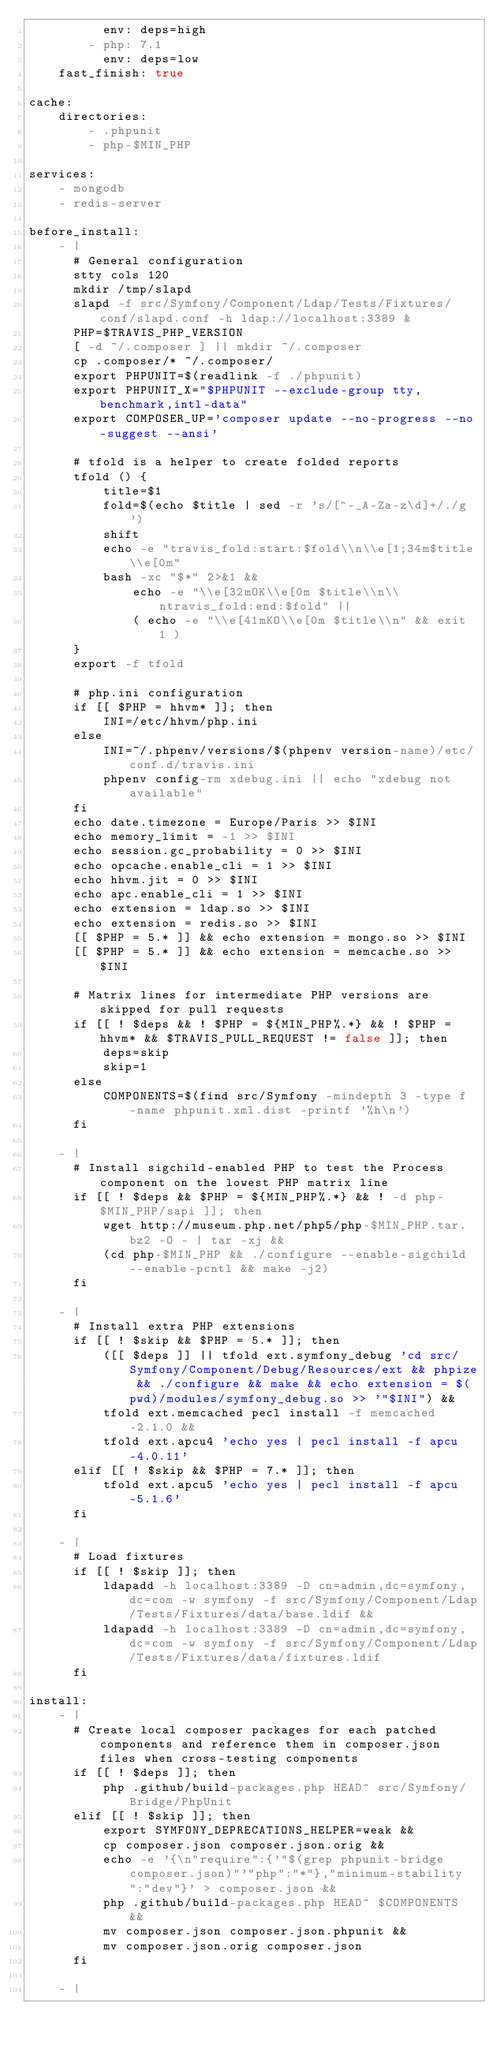Convert code to text. <code><loc_0><loc_0><loc_500><loc_500><_YAML_>          env: deps=high
        - php: 7.1
          env: deps=low
    fast_finish: true

cache:
    directories:
        - .phpunit
        - php-$MIN_PHP

services:
    - mongodb
    - redis-server

before_install:
    - |
      # General configuration
      stty cols 120
      mkdir /tmp/slapd
      slapd -f src/Symfony/Component/Ldap/Tests/Fixtures/conf/slapd.conf -h ldap://localhost:3389 &
      PHP=$TRAVIS_PHP_VERSION
      [ -d ~/.composer ] || mkdir ~/.composer
      cp .composer/* ~/.composer/
      export PHPUNIT=$(readlink -f ./phpunit)
      export PHPUNIT_X="$PHPUNIT --exclude-group tty,benchmark,intl-data"
      export COMPOSER_UP='composer update --no-progress --no-suggest --ansi'

      # tfold is a helper to create folded reports
      tfold () {
          title=$1
          fold=$(echo $title | sed -r 's/[^-_A-Za-z\d]+/./g')
          shift
          echo -e "travis_fold:start:$fold\\n\\e[1;34m$title\\e[0m"
          bash -xc "$*" 2>&1 &&
              echo -e "\\e[32mOK\\e[0m $title\\n\\ntravis_fold:end:$fold" ||
              ( echo -e "\\e[41mKO\\e[0m $title\\n" && exit 1 )
      }
      export -f tfold

      # php.ini configuration
      if [[ $PHP = hhvm* ]]; then
          INI=/etc/hhvm/php.ini
      else
          INI=~/.phpenv/versions/$(phpenv version-name)/etc/conf.d/travis.ini
          phpenv config-rm xdebug.ini || echo "xdebug not available"
      fi
      echo date.timezone = Europe/Paris >> $INI
      echo memory_limit = -1 >> $INI
      echo session.gc_probability = 0 >> $INI
      echo opcache.enable_cli = 1 >> $INI
      echo hhvm.jit = 0 >> $INI
      echo apc.enable_cli = 1 >> $INI
      echo extension = ldap.so >> $INI
      echo extension = redis.so >> $INI
      [[ $PHP = 5.* ]] && echo extension = mongo.so >> $INI
      [[ $PHP = 5.* ]] && echo extension = memcache.so >> $INI

      # Matrix lines for intermediate PHP versions are skipped for pull requests
      if [[ ! $deps && ! $PHP = ${MIN_PHP%.*} && ! $PHP = hhvm* && $TRAVIS_PULL_REQUEST != false ]]; then
          deps=skip
          skip=1
      else
          COMPONENTS=$(find src/Symfony -mindepth 3 -type f -name phpunit.xml.dist -printf '%h\n')
      fi

    - |
      # Install sigchild-enabled PHP to test the Process component on the lowest PHP matrix line
      if [[ ! $deps && $PHP = ${MIN_PHP%.*} && ! -d php-$MIN_PHP/sapi ]]; then
          wget http://museum.php.net/php5/php-$MIN_PHP.tar.bz2 -O - | tar -xj &&
          (cd php-$MIN_PHP && ./configure --enable-sigchild --enable-pcntl && make -j2)
      fi

    - |
      # Install extra PHP extensions
      if [[ ! $skip && $PHP = 5.* ]]; then
          ([[ $deps ]] || tfold ext.symfony_debug 'cd src/Symfony/Component/Debug/Resources/ext && phpize && ./configure && make && echo extension = $(pwd)/modules/symfony_debug.so >> '"$INI") &&
          tfold ext.memcached pecl install -f memcached-2.1.0 &&
          tfold ext.apcu4 'echo yes | pecl install -f apcu-4.0.11'
      elif [[ ! $skip && $PHP = 7.* ]]; then
          tfold ext.apcu5 'echo yes | pecl install -f apcu-5.1.6'
      fi

    - |
      # Load fixtures
      if [[ ! $skip ]]; then
          ldapadd -h localhost:3389 -D cn=admin,dc=symfony,dc=com -w symfony -f src/Symfony/Component/Ldap/Tests/Fixtures/data/base.ldif &&
          ldapadd -h localhost:3389 -D cn=admin,dc=symfony,dc=com -w symfony -f src/Symfony/Component/Ldap/Tests/Fixtures/data/fixtures.ldif
      fi

install:
    - |
      # Create local composer packages for each patched components and reference them in composer.json files when cross-testing components
      if [[ ! $deps ]]; then
          php .github/build-packages.php HEAD^ src/Symfony/Bridge/PhpUnit
      elif [[ ! $skip ]]; then
          export SYMFONY_DEPRECATIONS_HELPER=weak &&
          cp composer.json composer.json.orig &&
          echo -e '{\n"require":{'"$(grep phpunit-bridge composer.json)"'"php":"*"},"minimum-stability":"dev"}' > composer.json &&
          php .github/build-packages.php HEAD^ $COMPONENTS &&
          mv composer.json composer.json.phpunit &&
          mv composer.json.orig composer.json
      fi

    - |</code> 